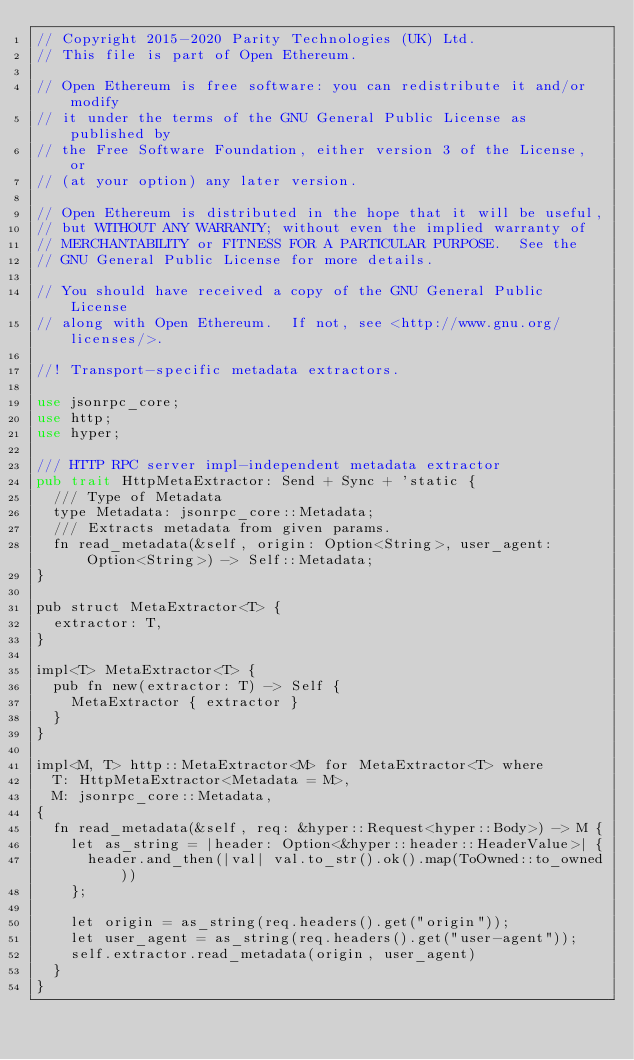<code> <loc_0><loc_0><loc_500><loc_500><_Rust_>// Copyright 2015-2020 Parity Technologies (UK) Ltd.
// This file is part of Open Ethereum.

// Open Ethereum is free software: you can redistribute it and/or modify
// it under the terms of the GNU General Public License as published by
// the Free Software Foundation, either version 3 of the License, or
// (at your option) any later version.

// Open Ethereum is distributed in the hope that it will be useful,
// but WITHOUT ANY WARRANTY; without even the implied warranty of
// MERCHANTABILITY or FITNESS FOR A PARTICULAR PURPOSE.  See the
// GNU General Public License for more details.

// You should have received a copy of the GNU General Public License
// along with Open Ethereum.  If not, see <http://www.gnu.org/licenses/>.

//! Transport-specific metadata extractors.

use jsonrpc_core;
use http;
use hyper;

/// HTTP RPC server impl-independent metadata extractor
pub trait HttpMetaExtractor: Send + Sync + 'static {
	/// Type of Metadata
	type Metadata: jsonrpc_core::Metadata;
	/// Extracts metadata from given params.
	fn read_metadata(&self, origin: Option<String>, user_agent: Option<String>) -> Self::Metadata;
}

pub struct MetaExtractor<T> {
	extractor: T,
}

impl<T> MetaExtractor<T> {
	pub fn new(extractor: T) -> Self {
		MetaExtractor { extractor }
	}
}

impl<M, T> http::MetaExtractor<M> for MetaExtractor<T> where
	T: HttpMetaExtractor<Metadata = M>,
	M: jsonrpc_core::Metadata,
{
	fn read_metadata(&self, req: &hyper::Request<hyper::Body>) -> M {
		let as_string = |header: Option<&hyper::header::HeaderValue>| {
			header.and_then(|val| val.to_str().ok().map(ToOwned::to_owned))
		};

		let origin = as_string(req.headers().get("origin"));
		let user_agent = as_string(req.headers().get("user-agent"));
		self.extractor.read_metadata(origin, user_agent)
	}
}
</code> 